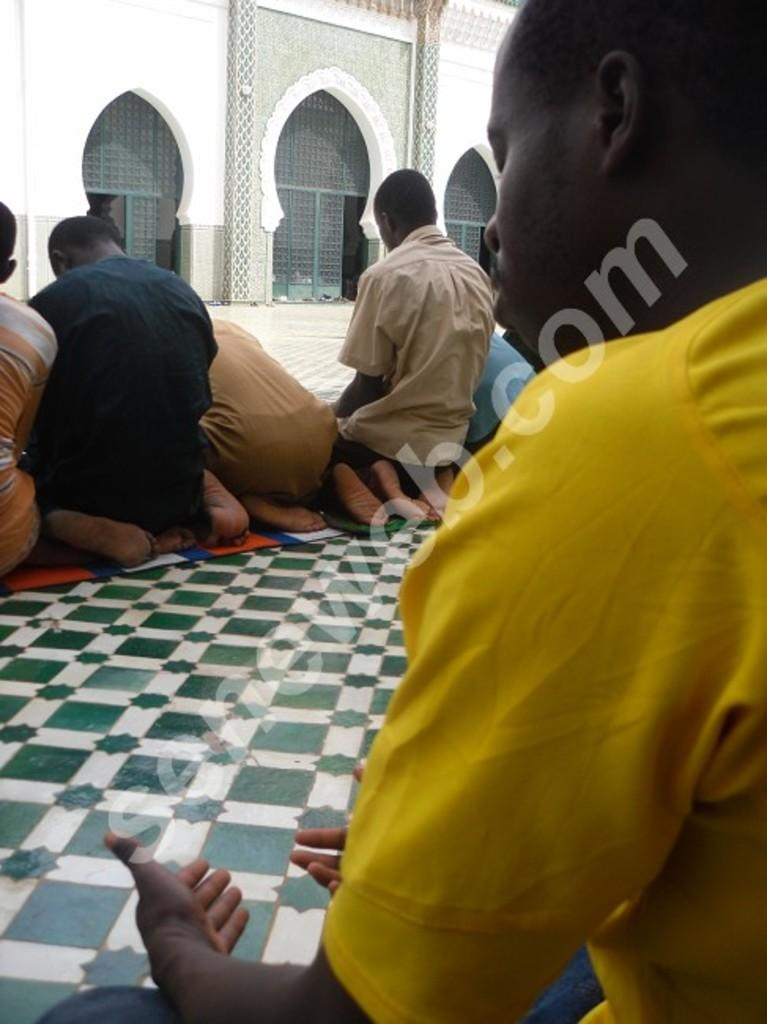What are the people in the image doing? There are groups of people sitting in the image. What is in front of the people? There is a wall in front of the people. Can you describe any additional features of the image? There is a watermark on the image. What type of mitten is the person wearing while driving in the image? There is no person wearing a mitten or driving in the image. What is the person's interest in the image? There is no person depicted in the image, so it is impossible to determine their interests. 